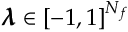Convert formula to latex. <formula><loc_0><loc_0><loc_500><loc_500>\pm b { \lambda } \in [ - 1 , 1 ] ^ { N _ { f } }</formula> 